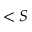<formula> <loc_0><loc_0><loc_500><loc_500>< S</formula> 